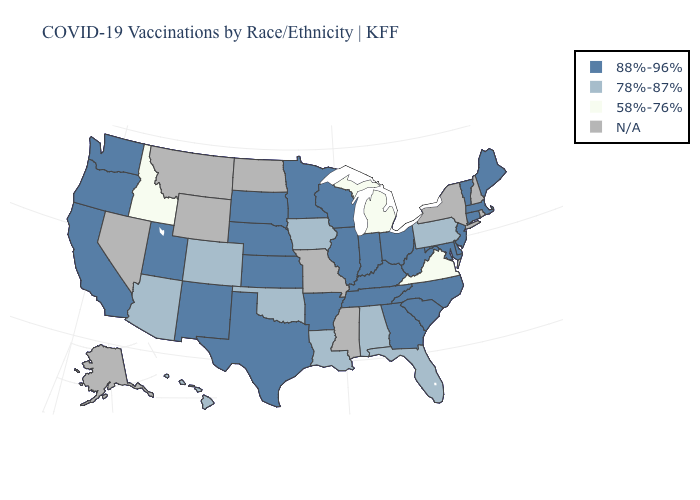Which states have the lowest value in the MidWest?
Short answer required. Michigan. Name the states that have a value in the range 58%-76%?
Concise answer only. Idaho, Michigan, Virginia. What is the lowest value in the Northeast?
Answer briefly. 78%-87%. Name the states that have a value in the range 88%-96%?
Give a very brief answer. Arkansas, California, Connecticut, Delaware, Georgia, Illinois, Indiana, Kansas, Kentucky, Maine, Maryland, Massachusetts, Minnesota, Nebraska, New Jersey, New Mexico, North Carolina, Ohio, Oregon, South Carolina, South Dakota, Tennessee, Texas, Utah, Vermont, Washington, West Virginia, Wisconsin. Among the states that border California , which have the lowest value?
Give a very brief answer. Arizona. What is the value of Alaska?
Answer briefly. N/A. Does the map have missing data?
Be succinct. Yes. What is the value of Nebraska?
Write a very short answer. 88%-96%. Does the first symbol in the legend represent the smallest category?
Write a very short answer. No. What is the lowest value in states that border Nebraska?
Concise answer only. 78%-87%. Does Michigan have the lowest value in the MidWest?
Answer briefly. Yes. What is the lowest value in the USA?
Give a very brief answer. 58%-76%. Which states have the lowest value in the USA?
Concise answer only. Idaho, Michigan, Virginia. What is the value of Kansas?
Concise answer only. 88%-96%. What is the value of South Carolina?
Concise answer only. 88%-96%. 